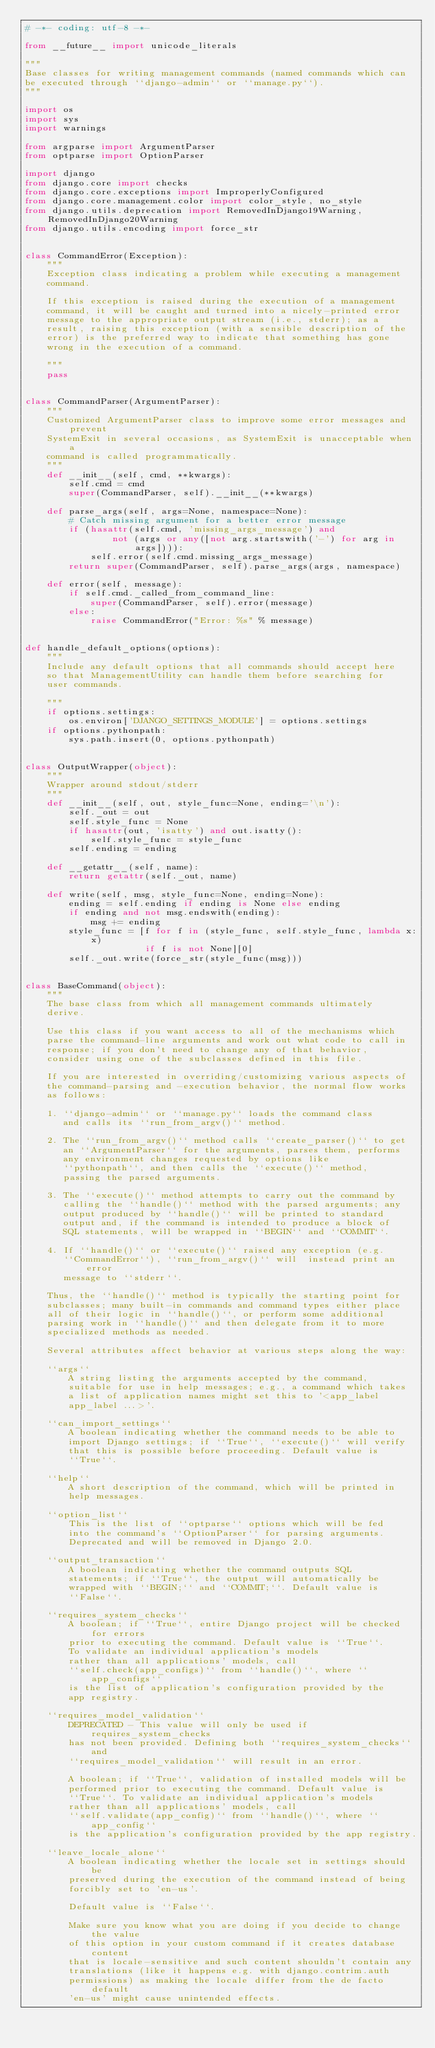<code> <loc_0><loc_0><loc_500><loc_500><_Python_># -*- coding: utf-8 -*-

from __future__ import unicode_literals

"""
Base classes for writing management commands (named commands which can
be executed through ``django-admin`` or ``manage.py``).
"""

import os
import sys
import warnings

from argparse import ArgumentParser
from optparse import OptionParser

import django
from django.core import checks
from django.core.exceptions import ImproperlyConfigured
from django.core.management.color import color_style, no_style
from django.utils.deprecation import RemovedInDjango19Warning, RemovedInDjango20Warning
from django.utils.encoding import force_str


class CommandError(Exception):
    """
    Exception class indicating a problem while executing a management
    command.

    If this exception is raised during the execution of a management
    command, it will be caught and turned into a nicely-printed error
    message to the appropriate output stream (i.e., stderr); as a
    result, raising this exception (with a sensible description of the
    error) is the preferred way to indicate that something has gone
    wrong in the execution of a command.

    """
    pass


class CommandParser(ArgumentParser):
    """
    Customized ArgumentParser class to improve some error messages and prevent
    SystemExit in several occasions, as SystemExit is unacceptable when a
    command is called programmatically.
    """
    def __init__(self, cmd, **kwargs):
        self.cmd = cmd
        super(CommandParser, self).__init__(**kwargs)

    def parse_args(self, args=None, namespace=None):
        # Catch missing argument for a better error message
        if (hasattr(self.cmd, 'missing_args_message') and
                not (args or any([not arg.startswith('-') for arg in args]))):
            self.error(self.cmd.missing_args_message)
        return super(CommandParser, self).parse_args(args, namespace)

    def error(self, message):
        if self.cmd._called_from_command_line:
            super(CommandParser, self).error(message)
        else:
            raise CommandError("Error: %s" % message)


def handle_default_options(options):
    """
    Include any default options that all commands should accept here
    so that ManagementUtility can handle them before searching for
    user commands.

    """
    if options.settings:
        os.environ['DJANGO_SETTINGS_MODULE'] = options.settings
    if options.pythonpath:
        sys.path.insert(0, options.pythonpath)


class OutputWrapper(object):
    """
    Wrapper around stdout/stderr
    """
    def __init__(self, out, style_func=None, ending='\n'):
        self._out = out
        self.style_func = None
        if hasattr(out, 'isatty') and out.isatty():
            self.style_func = style_func
        self.ending = ending

    def __getattr__(self, name):
        return getattr(self._out, name)

    def write(self, msg, style_func=None, ending=None):
        ending = self.ending if ending is None else ending
        if ending and not msg.endswith(ending):
            msg += ending
        style_func = [f for f in (style_func, self.style_func, lambda x:x)
                      if f is not None][0]
        self._out.write(force_str(style_func(msg)))


class BaseCommand(object):
    """
    The base class from which all management commands ultimately
    derive.

    Use this class if you want access to all of the mechanisms which
    parse the command-line arguments and work out what code to call in
    response; if you don't need to change any of that behavior,
    consider using one of the subclasses defined in this file.

    If you are interested in overriding/customizing various aspects of
    the command-parsing and -execution behavior, the normal flow works
    as follows:

    1. ``django-admin`` or ``manage.py`` loads the command class
       and calls its ``run_from_argv()`` method.

    2. The ``run_from_argv()`` method calls ``create_parser()`` to get
       an ``ArgumentParser`` for the arguments, parses them, performs
       any environment changes requested by options like
       ``pythonpath``, and then calls the ``execute()`` method,
       passing the parsed arguments.

    3. The ``execute()`` method attempts to carry out the command by
       calling the ``handle()`` method with the parsed arguments; any
       output produced by ``handle()`` will be printed to standard
       output and, if the command is intended to produce a block of
       SQL statements, will be wrapped in ``BEGIN`` and ``COMMIT``.

    4. If ``handle()`` or ``execute()`` raised any exception (e.g.
       ``CommandError``), ``run_from_argv()`` will  instead print an error
       message to ``stderr``.

    Thus, the ``handle()`` method is typically the starting point for
    subclasses; many built-in commands and command types either place
    all of their logic in ``handle()``, or perform some additional
    parsing work in ``handle()`` and then delegate from it to more
    specialized methods as needed.

    Several attributes affect behavior at various steps along the way:

    ``args``
        A string listing the arguments accepted by the command,
        suitable for use in help messages; e.g., a command which takes
        a list of application names might set this to '<app_label
        app_label ...>'.

    ``can_import_settings``
        A boolean indicating whether the command needs to be able to
        import Django settings; if ``True``, ``execute()`` will verify
        that this is possible before proceeding. Default value is
        ``True``.

    ``help``
        A short description of the command, which will be printed in
        help messages.

    ``option_list``
        This is the list of ``optparse`` options which will be fed
        into the command's ``OptionParser`` for parsing arguments.
        Deprecated and will be removed in Django 2.0.

    ``output_transaction``
        A boolean indicating whether the command outputs SQL
        statements; if ``True``, the output will automatically be
        wrapped with ``BEGIN;`` and ``COMMIT;``. Default value is
        ``False``.

    ``requires_system_checks``
        A boolean; if ``True``, entire Django project will be checked for errors
        prior to executing the command. Default value is ``True``.
        To validate an individual application's models
        rather than all applications' models, call
        ``self.check(app_configs)`` from ``handle()``, where ``app_configs``
        is the list of application's configuration provided by the
        app registry.

    ``requires_model_validation``
        DEPRECATED - This value will only be used if requires_system_checks
        has not been provided. Defining both ``requires_system_checks`` and
        ``requires_model_validation`` will result in an error.

        A boolean; if ``True``, validation of installed models will be
        performed prior to executing the command. Default value is
        ``True``. To validate an individual application's models
        rather than all applications' models, call
        ``self.validate(app_config)`` from ``handle()``, where ``app_config``
        is the application's configuration provided by the app registry.

    ``leave_locale_alone``
        A boolean indicating whether the locale set in settings should be
        preserved during the execution of the command instead of being
        forcibly set to 'en-us'.

        Default value is ``False``.

        Make sure you know what you are doing if you decide to change the value
        of this option in your custom command if it creates database content
        that is locale-sensitive and such content shouldn't contain any
        translations (like it happens e.g. with django.contrim.auth
        permissions) as making the locale differ from the de facto default
        'en-us' might cause unintended effects.
</code> 